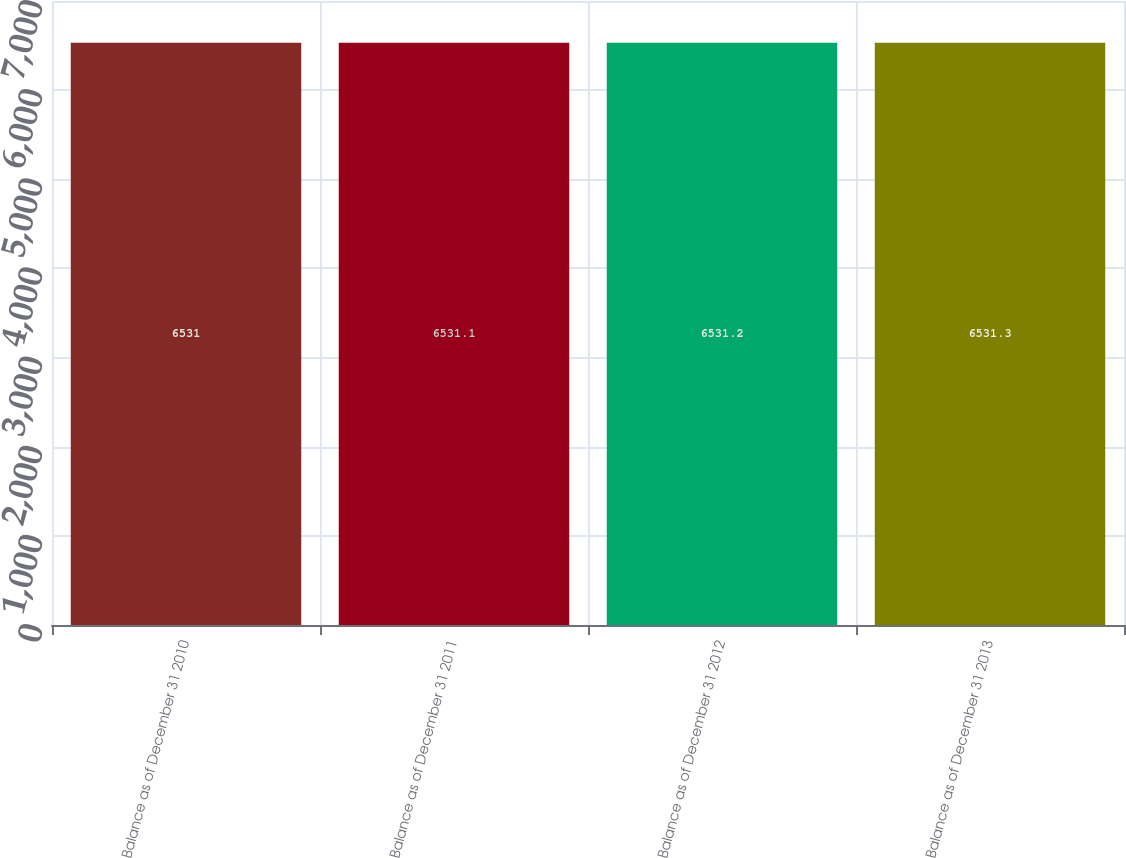<chart> <loc_0><loc_0><loc_500><loc_500><bar_chart><fcel>Balance as of December 31 2010<fcel>Balance as of December 31 2011<fcel>Balance as of December 31 2012<fcel>Balance as of December 31 2013<nl><fcel>6531<fcel>6531.1<fcel>6531.2<fcel>6531.3<nl></chart> 